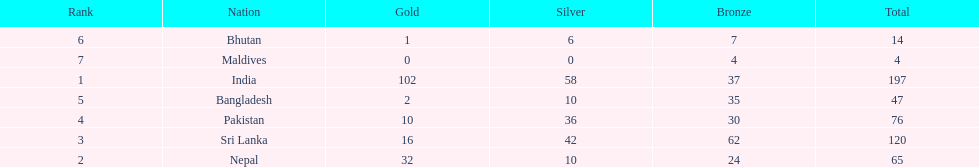What countries attended the 1999 south asian games? India, Nepal, Sri Lanka, Pakistan, Bangladesh, Bhutan, Maldives. Which of these countries had 32 gold medals? Nepal. 